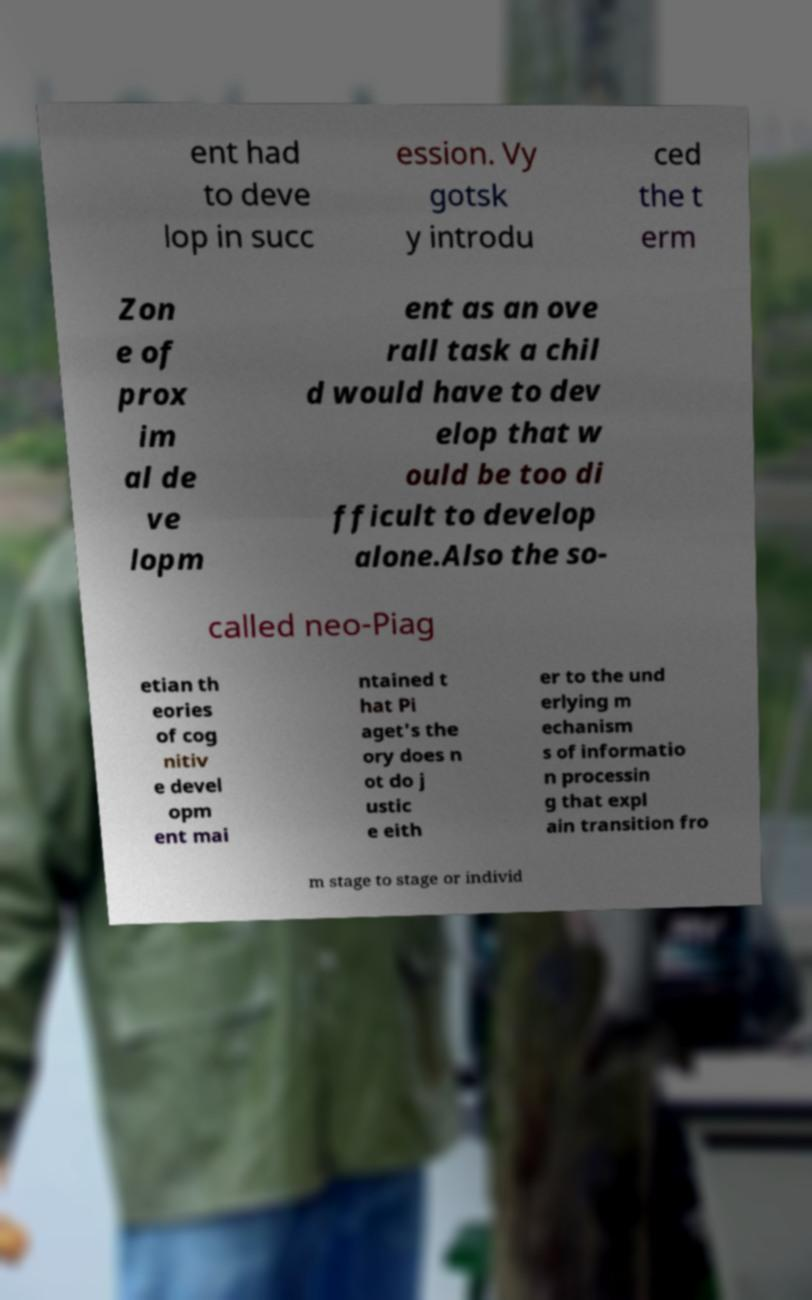What messages or text are displayed in this image? I need them in a readable, typed format. ent had to deve lop in succ ession. Vy gotsk y introdu ced the t erm Zon e of prox im al de ve lopm ent as an ove rall task a chil d would have to dev elop that w ould be too di fficult to develop alone.Also the so- called neo-Piag etian th eories of cog nitiv e devel opm ent mai ntained t hat Pi aget's the ory does n ot do j ustic e eith er to the und erlying m echanism s of informatio n processin g that expl ain transition fro m stage to stage or individ 